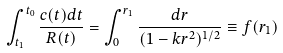<formula> <loc_0><loc_0><loc_500><loc_500>\int _ { t _ { 1 } } ^ { t _ { 0 } } \frac { c ( t ) d t } { R ( t ) } = \int _ { 0 } ^ { r _ { 1 } } \frac { d r } { ( 1 - k r ^ { 2 } ) ^ { 1 / 2 } } \equiv f ( r _ { 1 } )</formula> 